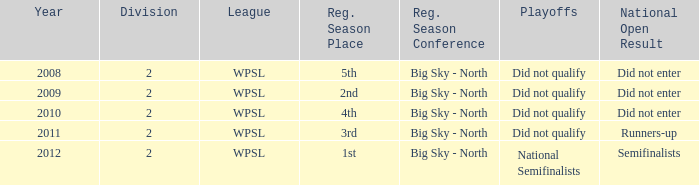What league was involved in 2008? WPSL. 